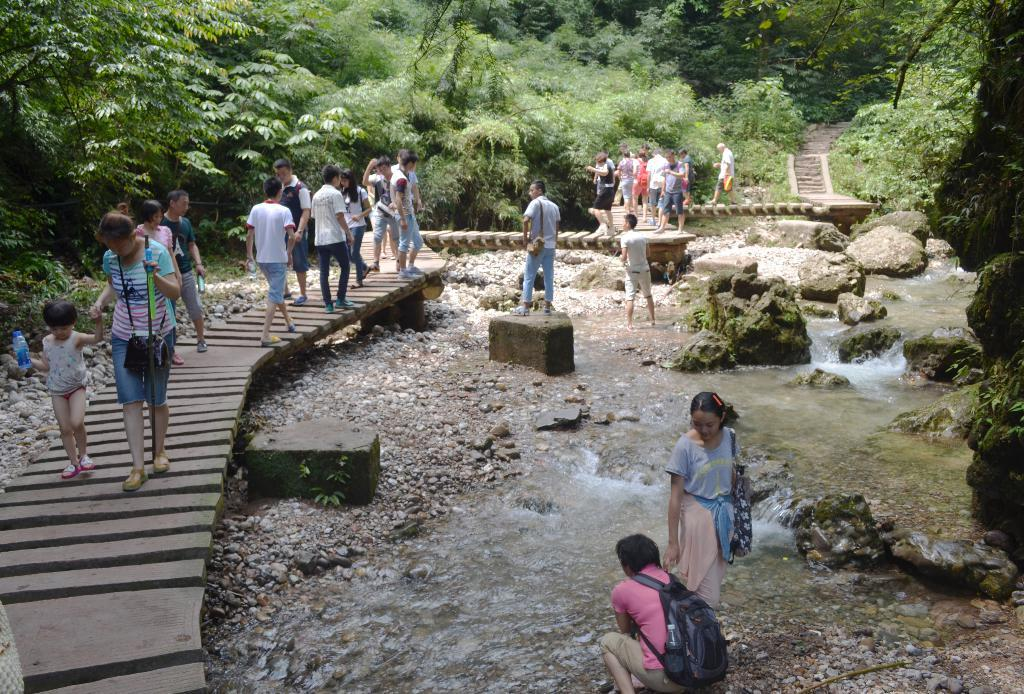What is the main subject of the image? There is a beautiful woman in the image. What is the woman doing in the image? The woman is walking with a baby. What can be seen on the right side of the image? Water is flowing on the right side of the image. What type of vegetation is visible in the background of the image? There are green trees in the background of the image. What type of glove is the woman wearing in the image? There is no glove visible in the image. Can you tell me where the nearest hospital is located in the image? There is no hospital present in the image. 